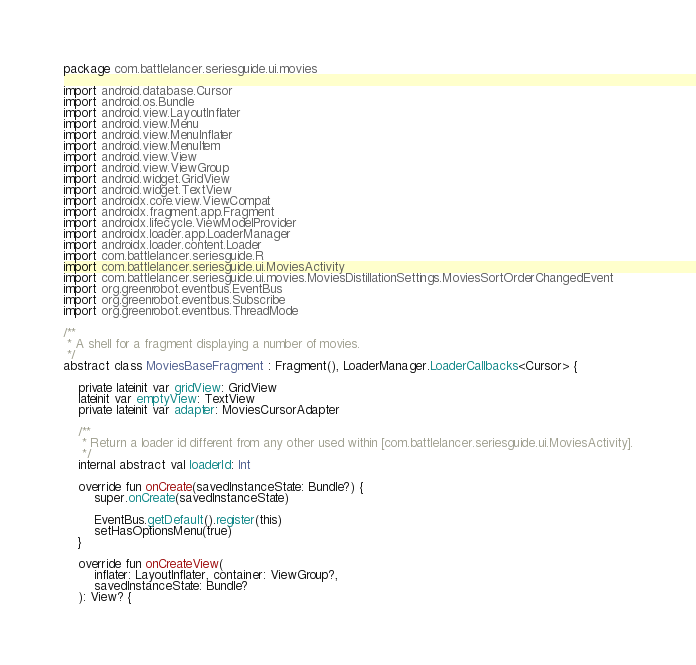Convert code to text. <code><loc_0><loc_0><loc_500><loc_500><_Kotlin_>package com.battlelancer.seriesguide.ui.movies

import android.database.Cursor
import android.os.Bundle
import android.view.LayoutInflater
import android.view.Menu
import android.view.MenuInflater
import android.view.MenuItem
import android.view.View
import android.view.ViewGroup
import android.widget.GridView
import android.widget.TextView
import androidx.core.view.ViewCompat
import androidx.fragment.app.Fragment
import androidx.lifecycle.ViewModelProvider
import androidx.loader.app.LoaderManager
import androidx.loader.content.Loader
import com.battlelancer.seriesguide.R
import com.battlelancer.seriesguide.ui.MoviesActivity
import com.battlelancer.seriesguide.ui.movies.MoviesDistillationSettings.MoviesSortOrderChangedEvent
import org.greenrobot.eventbus.EventBus
import org.greenrobot.eventbus.Subscribe
import org.greenrobot.eventbus.ThreadMode

/**
 * A shell for a fragment displaying a number of movies.
 */
abstract class MoviesBaseFragment : Fragment(), LoaderManager.LoaderCallbacks<Cursor> {

    private lateinit var gridView: GridView
    lateinit var emptyView: TextView
    private lateinit var adapter: MoviesCursorAdapter

    /**
     * Return a loader id different from any other used within [com.battlelancer.seriesguide.ui.MoviesActivity].
     */
    internal abstract val loaderId: Int

    override fun onCreate(savedInstanceState: Bundle?) {
        super.onCreate(savedInstanceState)

        EventBus.getDefault().register(this)
        setHasOptionsMenu(true)
    }

    override fun onCreateView(
        inflater: LayoutInflater, container: ViewGroup?,
        savedInstanceState: Bundle?
    ): View? {</code> 